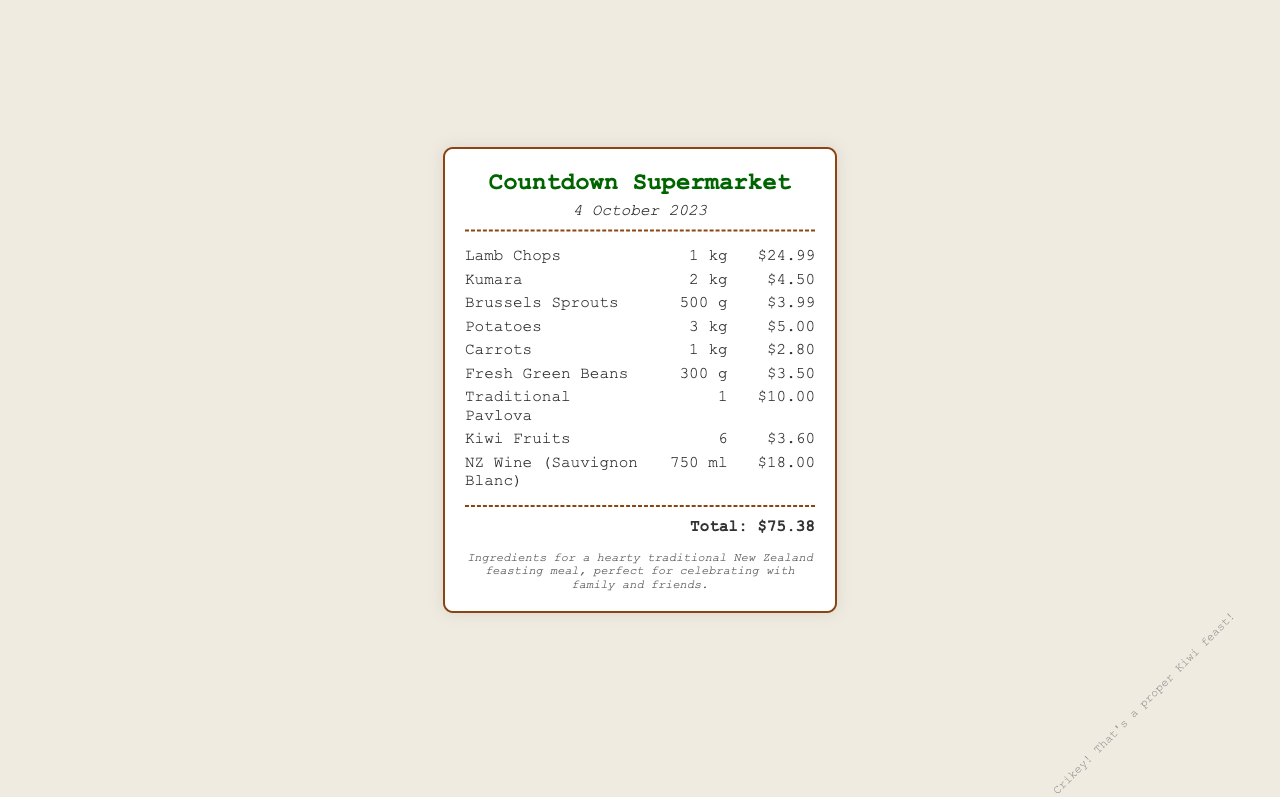What is the date of the receipt? The date of the receipt is clearly mentioned at the top of the document under the header section.
Answer: 4 October 2023 What is the name of the store? The store name is prominently displayed at the header of the receipt, indicating where the shopping was done.
Answer: Countdown Supermarket How much did the Lamb Chops cost? The price of the Lamb Chops is listed clearly with the quantity in that line, providing specific pricing information.
Answer: $24.99 What is the total amount spent on groceries? The total amount at the bottom of the receipt summarizes the total cost of all purchased items.
Answer: $75.38 How many Kiwi Fruits were purchased? The quantity of Kiwi Fruits is specified as part of the itemized list in the receipt.
Answer: 6 What ingredient is used to make a traditional dessert mentioned in the receipt? The receipt lists a dessert item that is traditional in New Zealand, indicating its relevance to the meal.
Answer: Traditional Pavlova What is the quantity of Fresh Green Beans purchased? The quantity of the Fresh Green Beans is detailed along with its price under the itemized list.
Answer: 300 g What type of wine was bought? The type of wine is specified in the item list, offering insight into what was included in the purchase.
Answer: Sauvignon Blanc How many kilograms of Potatoes were purchased? The weight of the Potatoes is outlined in the itemized section, providing a straightforward answer about this ingredient.
Answer: 3 kg 